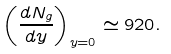<formula> <loc_0><loc_0><loc_500><loc_500>\left ( \frac { d N _ { g } } { d y } \right ) _ { y = 0 } \simeq 9 2 0 .</formula> 